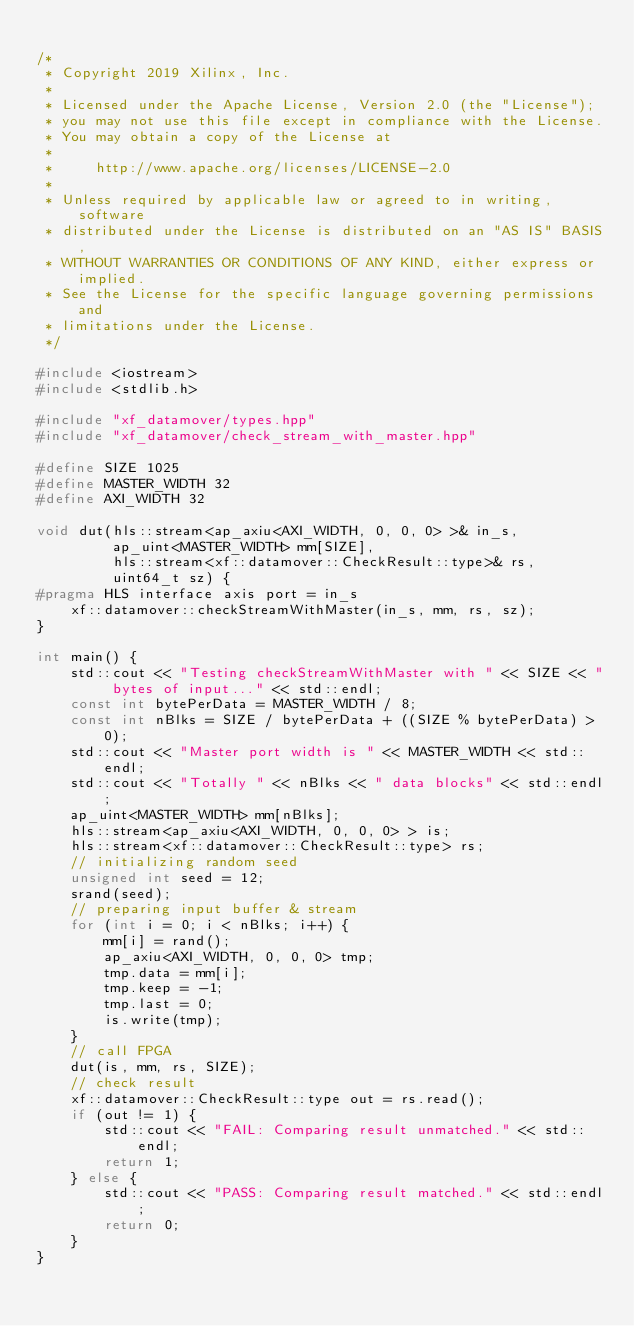<code> <loc_0><loc_0><loc_500><loc_500><_C++_>
/*
 * Copyright 2019 Xilinx, Inc.
 *
 * Licensed under the Apache License, Version 2.0 (the "License");
 * you may not use this file except in compliance with the License.
 * You may obtain a copy of the License at
 *
 *     http://www.apache.org/licenses/LICENSE-2.0
 *
 * Unless required by applicable law or agreed to in writing, software
 * distributed under the License is distributed on an "AS IS" BASIS,
 * WITHOUT WARRANTIES OR CONDITIONS OF ANY KIND, either express or implied.
 * See the License for the specific language governing permissions and
 * limitations under the License.
 */

#include <iostream>
#include <stdlib.h>

#include "xf_datamover/types.hpp"
#include "xf_datamover/check_stream_with_master.hpp"

#define SIZE 1025
#define MASTER_WIDTH 32
#define AXI_WIDTH 32

void dut(hls::stream<ap_axiu<AXI_WIDTH, 0, 0, 0> >& in_s,
         ap_uint<MASTER_WIDTH> mm[SIZE],
         hls::stream<xf::datamover::CheckResult::type>& rs,
         uint64_t sz) {
#pragma HLS interface axis port = in_s
    xf::datamover::checkStreamWithMaster(in_s, mm, rs, sz);
}

int main() {
    std::cout << "Testing checkStreamWithMaster with " << SIZE << " bytes of input..." << std::endl;
    const int bytePerData = MASTER_WIDTH / 8;
    const int nBlks = SIZE / bytePerData + ((SIZE % bytePerData) > 0);
    std::cout << "Master port width is " << MASTER_WIDTH << std::endl;
    std::cout << "Totally " << nBlks << " data blocks" << std::endl;
    ap_uint<MASTER_WIDTH> mm[nBlks];
    hls::stream<ap_axiu<AXI_WIDTH, 0, 0, 0> > is;
    hls::stream<xf::datamover::CheckResult::type> rs;
    // initializing random seed
    unsigned int seed = 12;
    srand(seed);
    // preparing input buffer & stream
    for (int i = 0; i < nBlks; i++) {
        mm[i] = rand();
        ap_axiu<AXI_WIDTH, 0, 0, 0> tmp;
        tmp.data = mm[i];
        tmp.keep = -1;
        tmp.last = 0;
        is.write(tmp);
    }
    // call FPGA
    dut(is, mm, rs, SIZE);
    // check result
    xf::datamover::CheckResult::type out = rs.read();
    if (out != 1) {
        std::cout << "FAIL: Comparing result unmatched." << std::endl;
        return 1;
    } else {
        std::cout << "PASS: Comparing result matched." << std::endl;
        return 0;
    }
}
</code> 